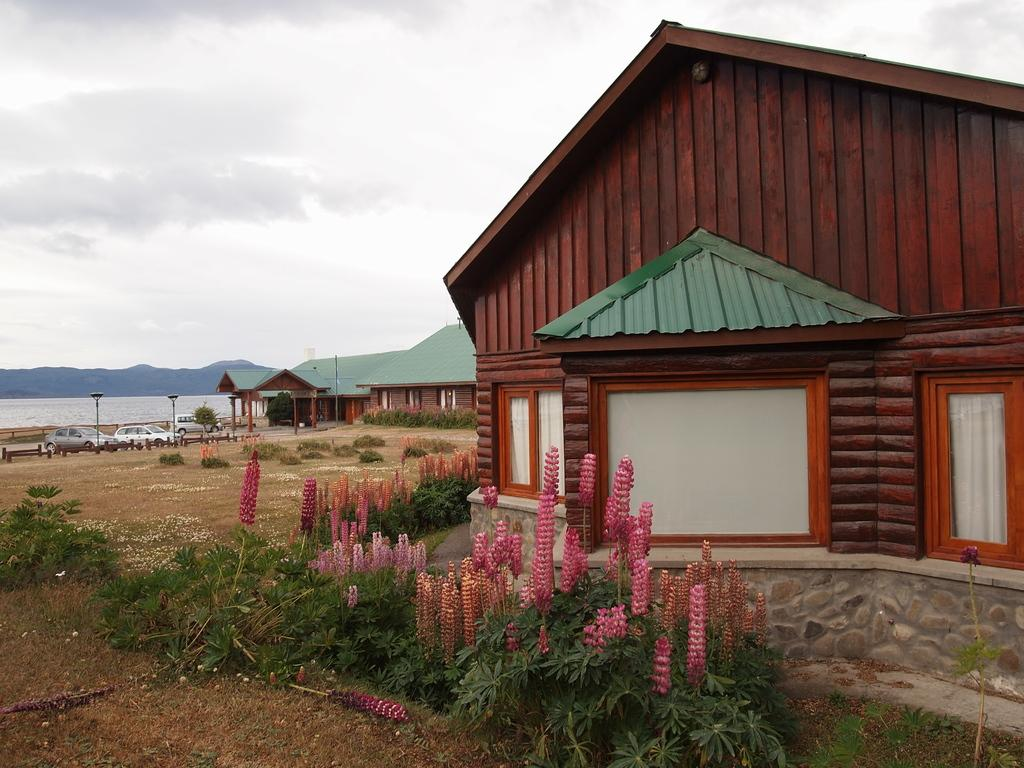What type of structures can be seen in the image? There are houses in the image. What is located in front of the houses? Lamp posts are present in front of the houses. What mode of transportation is parked near the houses? Cars are parked in front of the houses. What can be seen in the distance in the background of the image? There is water and mountains visible in the background of the image. What type of vein can be seen in the image? There is no vein present in the image; it is a scene featuring houses, lamp posts, cars, water, and mountains. 